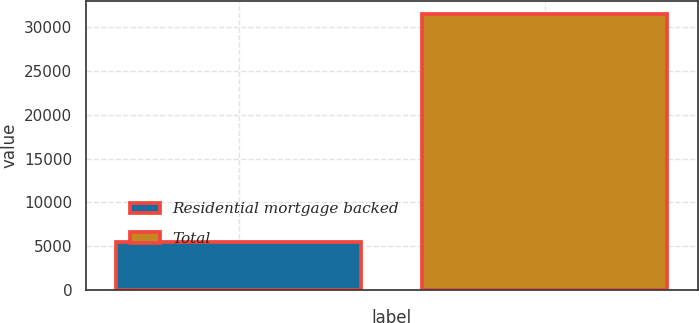Convert chart to OTSL. <chart><loc_0><loc_0><loc_500><loc_500><bar_chart><fcel>Residential mortgage backed<fcel>Total<nl><fcel>5429<fcel>31472<nl></chart> 